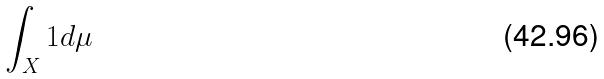<formula> <loc_0><loc_0><loc_500><loc_500>\int _ { X } 1 d \mu</formula> 